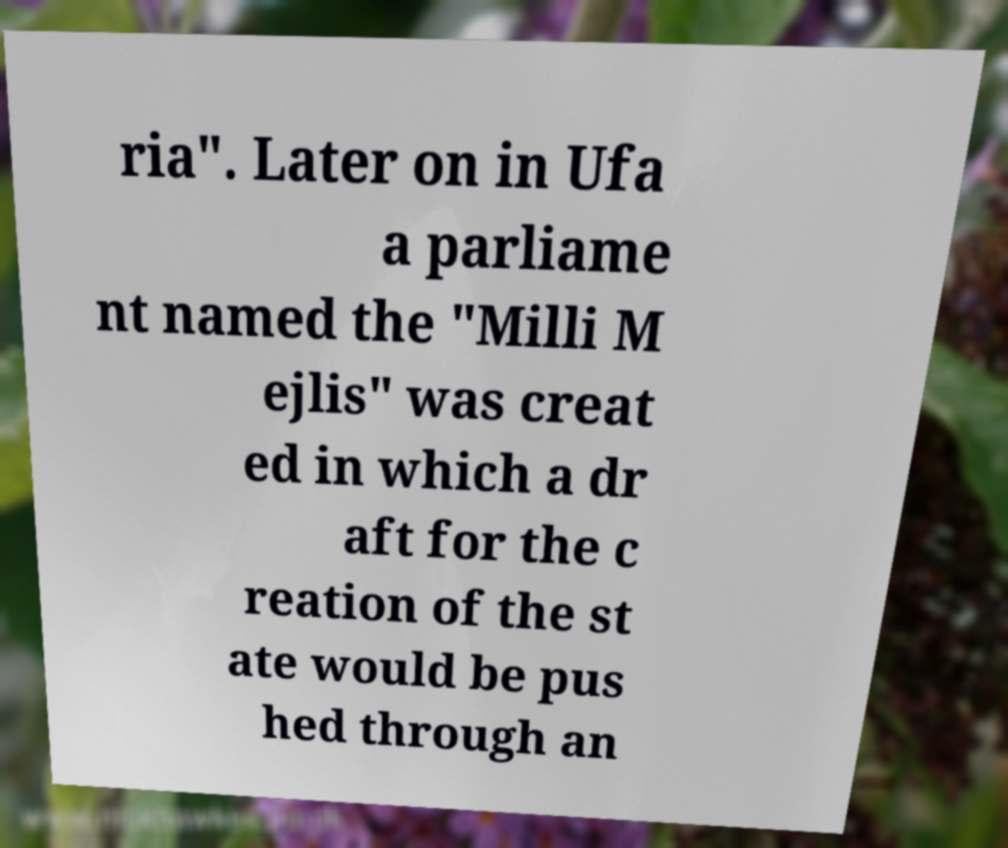Please identify and transcribe the text found in this image. ria". Later on in Ufa a parliame nt named the "Milli M ejlis" was creat ed in which a dr aft for the c reation of the st ate would be pus hed through an 